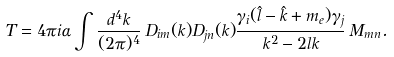Convert formula to latex. <formula><loc_0><loc_0><loc_500><loc_500>T = 4 \pi i \alpha \int \frac { d ^ { 4 } k } { ( 2 \pi ) ^ { 4 } } \, D _ { i m } ( k ) D _ { j n } ( k ) \frac { \gamma _ { i } ( { \hat { l } } - { \hat { k } } + m _ { e } ) \gamma _ { j } } { k ^ { 2 } - 2 l k } \, M _ { m n } .</formula> 